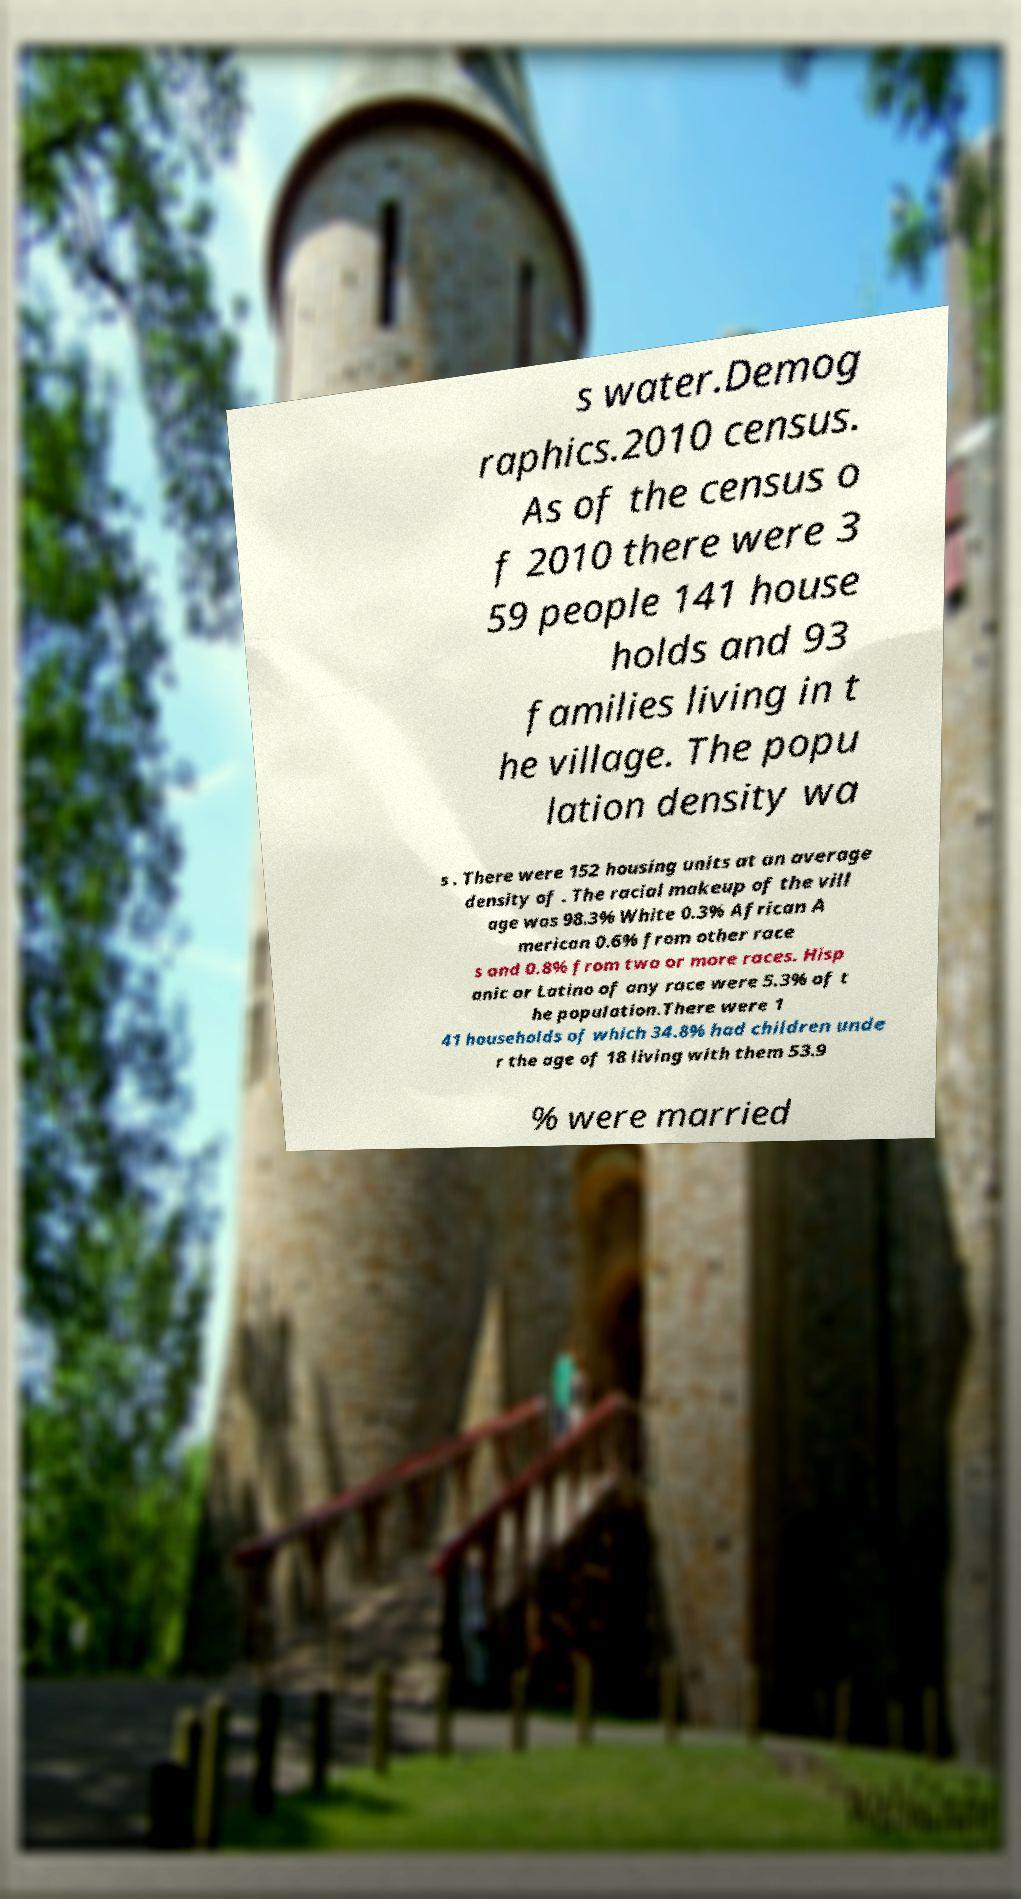I need the written content from this picture converted into text. Can you do that? s water.Demog raphics.2010 census. As of the census o f 2010 there were 3 59 people 141 house holds and 93 families living in t he village. The popu lation density wa s . There were 152 housing units at an average density of . The racial makeup of the vill age was 98.3% White 0.3% African A merican 0.6% from other race s and 0.8% from two or more races. Hisp anic or Latino of any race were 5.3% of t he population.There were 1 41 households of which 34.8% had children unde r the age of 18 living with them 53.9 % were married 